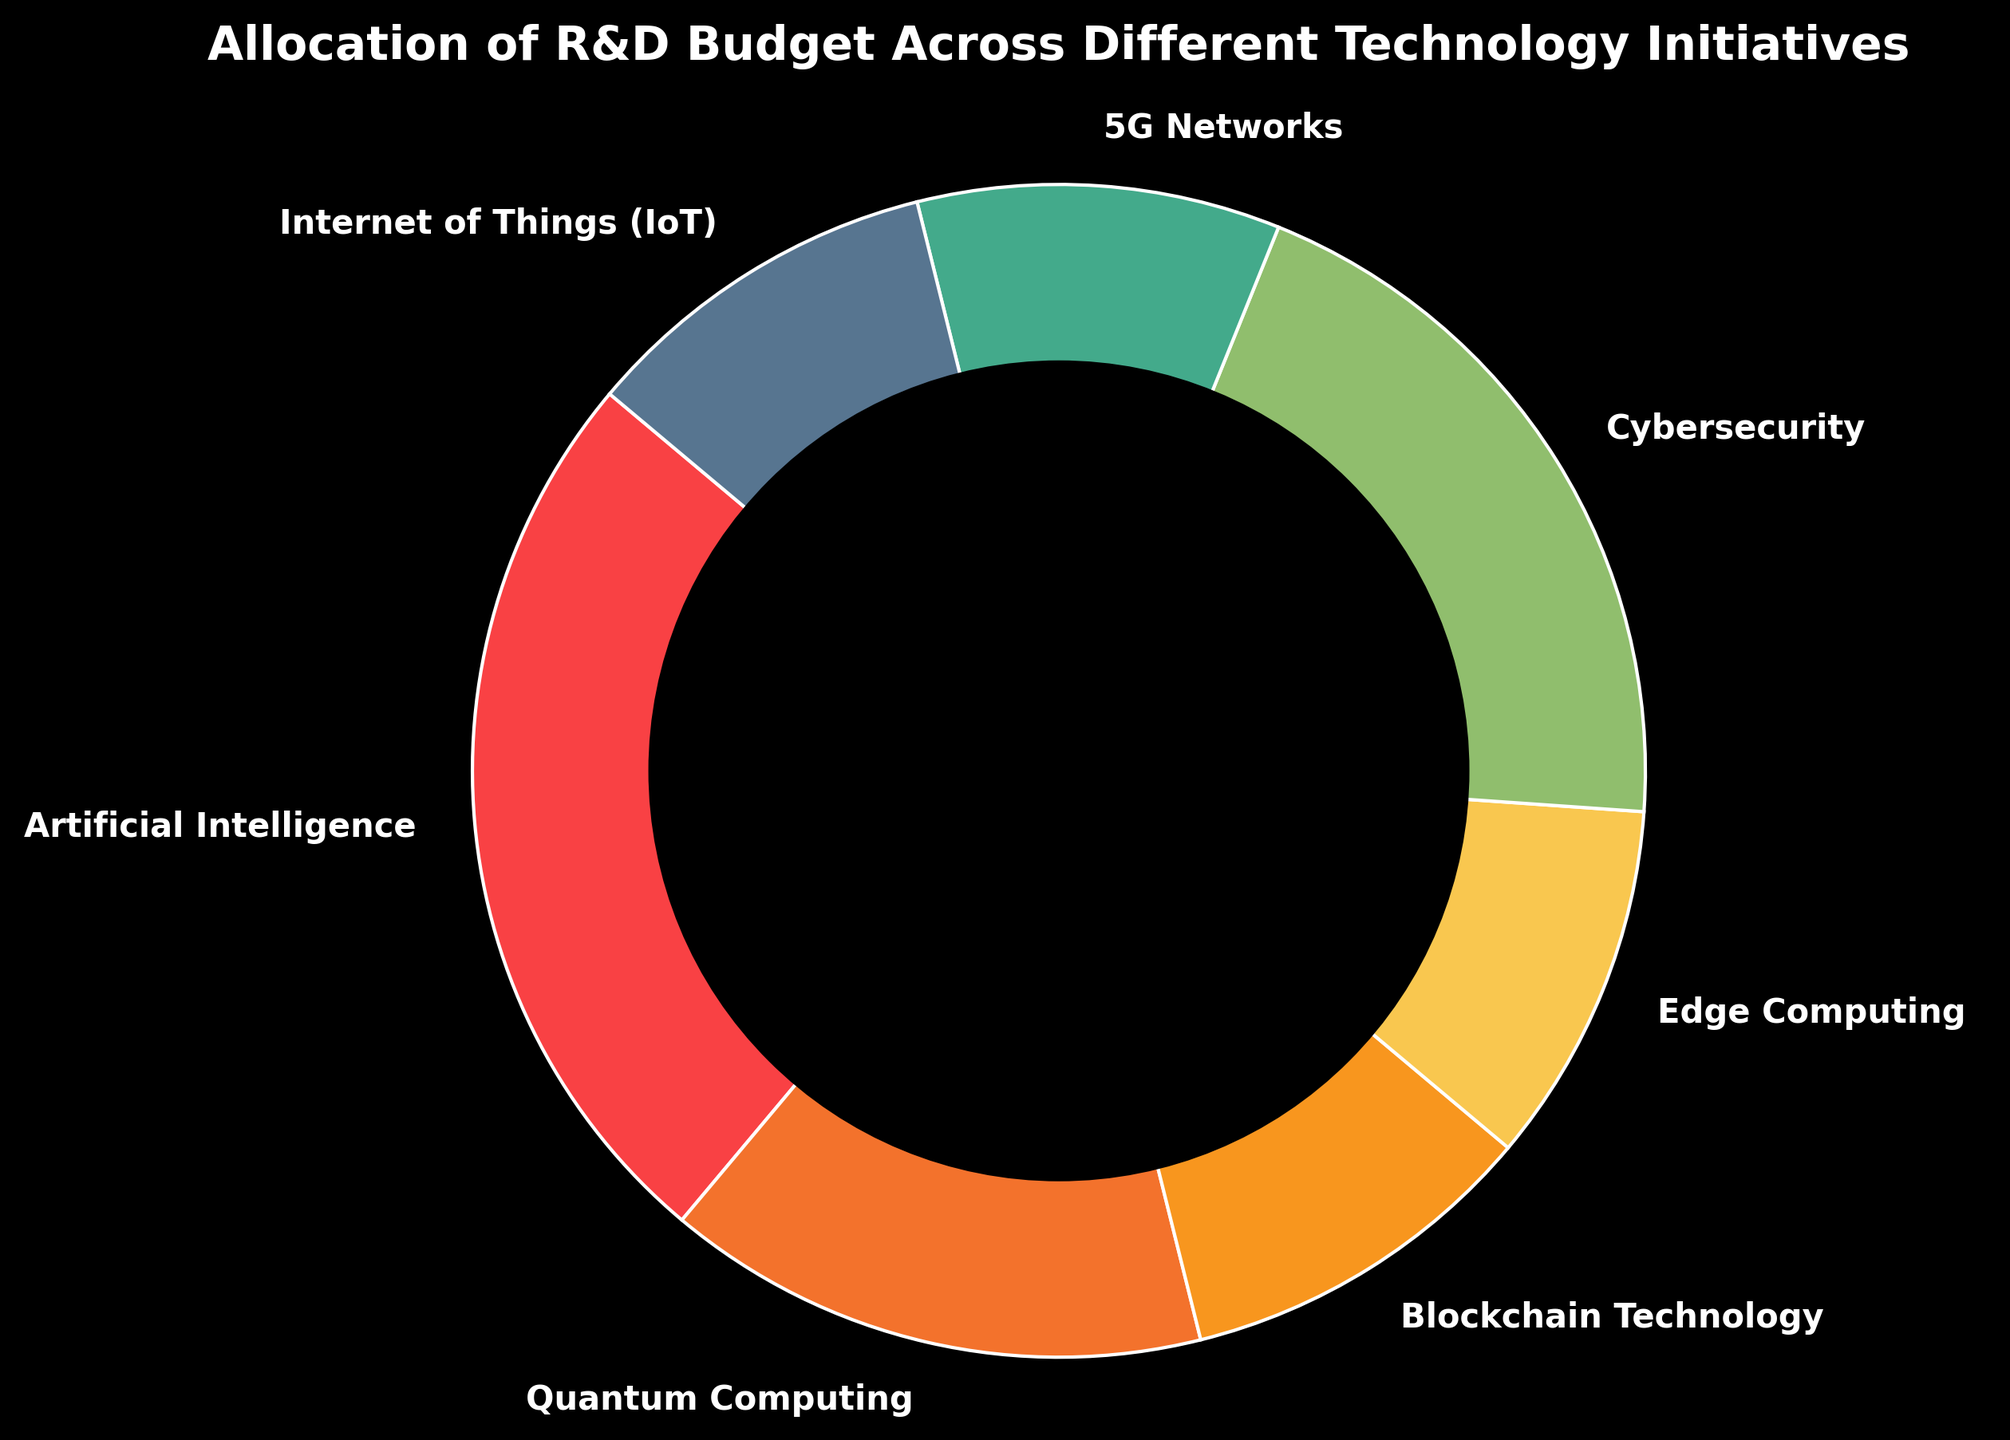Which technology initiative receives the largest share of the R&D budget? The chart shows the budget allocation as a ring chart. The largest wedge represents Artificial Intelligence, allocating 25% of the R&D budget.
Answer: Artificial Intelligence Which technology initiatives each receive 10% of the R&D budget? By observing the chart, the wedges labeled Blockchain Technology, Edge Computing, 5G Networks, and the Internet of Things (IoT) each occupy an equal portion of 10%.
Answer: Blockchain Technology, Edge Computing, 5G Networks, Internet of Things (IoT) What is the combined percentage of the R&D budget for Blockchain Technology, Edge Computing, 5G Networks, and the Internet of Things (IoT)? Add up the percentages for Blockchain Technology (10%), Edge Computing (10%), 5G Networks (10%), and Internet of Things (IoT) (10%). The total is 10 + 10 + 10 + 10 = 40%.
Answer: 40% How much more budget is allocated to Cybersecurity compared to Quantum Computing? The percentage allocated to Cybersecurity is 20%, and for Quantum Computing, it is 15%. The difference between them is 20% - 15% = 5%.
Answer: 5% Which technology initiative has a budget closest in size to that of Edge Computing? Both Blockchain Technology, Edge Computing, 5G Networks, and the Internet of Things (IoT) receive the same amount of 10%. Therefore, they all have budgets closest to Edge Computing.
Answer: Blockchain Technology, 5G Networks, Internet of Things (IoT) How does the budget allocated to 5G Networks compare to that allocated to Quantum Computing? The chart shows that 5G Networks and Quantum Computing receive different percentages: 5G Networks get 10%, while Quantum Computing gets 15%, making Quantum Computing higher by 5%.
Answer: Quantum Computing gets 5% more than 5G Networks How many technology initiatives receive more than 15% of the R&D budget? By observing the budget allocations: Artificial Intelligence (25%) and Cybersecurity (20%) are the only initiatives receiving more than 15%.
Answer: 2 What is the difference in the budget allocation between the highest and lowest funded technology initiatives? The highest allocation is for Artificial Intelligence at 25%, and the lowest is shared by Blockchain Technology, Edge Computing, 5G Networks, and the Internet of Things (IoT) each at 10%. The difference is 25% - 10% = 15%.
Answer: 15% Which technology initiative is represented in green in the chart? By referring to the visualization, the wedge colored green represents Cybersecurity.
Answer: Cybersecurity 